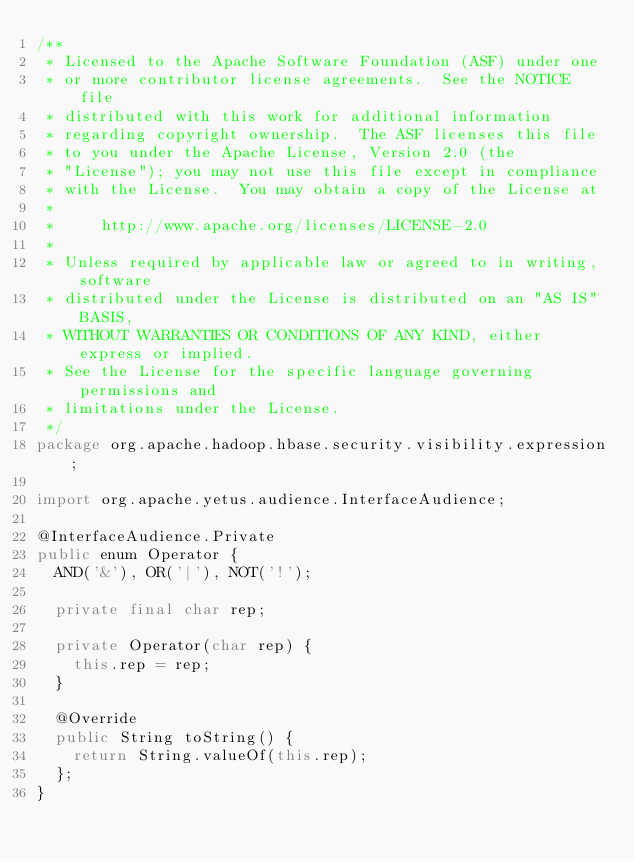Convert code to text. <code><loc_0><loc_0><loc_500><loc_500><_Java_>/**
 * Licensed to the Apache Software Foundation (ASF) under one
 * or more contributor license agreements.  See the NOTICE file
 * distributed with this work for additional information
 * regarding copyright ownership.  The ASF licenses this file
 * to you under the Apache License, Version 2.0 (the
 * "License"); you may not use this file except in compliance
 * with the License.  You may obtain a copy of the License at
 *
 *     http://www.apache.org/licenses/LICENSE-2.0
 *
 * Unless required by applicable law or agreed to in writing, software
 * distributed under the License is distributed on an "AS IS" BASIS,
 * WITHOUT WARRANTIES OR CONDITIONS OF ANY KIND, either express or implied.
 * See the License for the specific language governing permissions and
 * limitations under the License.
 */
package org.apache.hadoop.hbase.security.visibility.expression;

import org.apache.yetus.audience.InterfaceAudience;

@InterfaceAudience.Private
public enum Operator {
  AND('&'), OR('|'), NOT('!');

  private final char rep;

  private Operator(char rep) {
    this.rep = rep;
  }

  @Override
  public String toString() {
    return String.valueOf(this.rep);
  };
}
</code> 